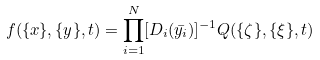<formula> <loc_0><loc_0><loc_500><loc_500>f ( \{ x \} , \{ y \} , t ) = { \prod _ { i = 1 } ^ { N } [ D _ { i } ( \bar { y _ { i } } ) ] ^ { - 1 } } Q ( \{ \zeta \} , \{ \xi \} , t )</formula> 